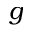<formula> <loc_0><loc_0><loc_500><loc_500>g</formula> 